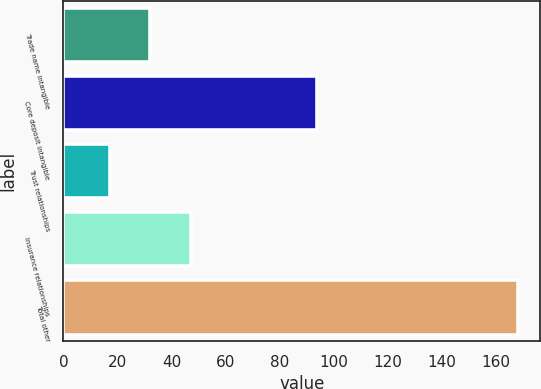Convert chart. <chart><loc_0><loc_0><loc_500><loc_500><bar_chart><fcel>Trade name intangible<fcel>Core deposit intangible<fcel>Trust relationships<fcel>Insurance relationships<fcel>Total other<nl><fcel>32.18<fcel>93.9<fcel>17.1<fcel>47.26<fcel>167.9<nl></chart> 